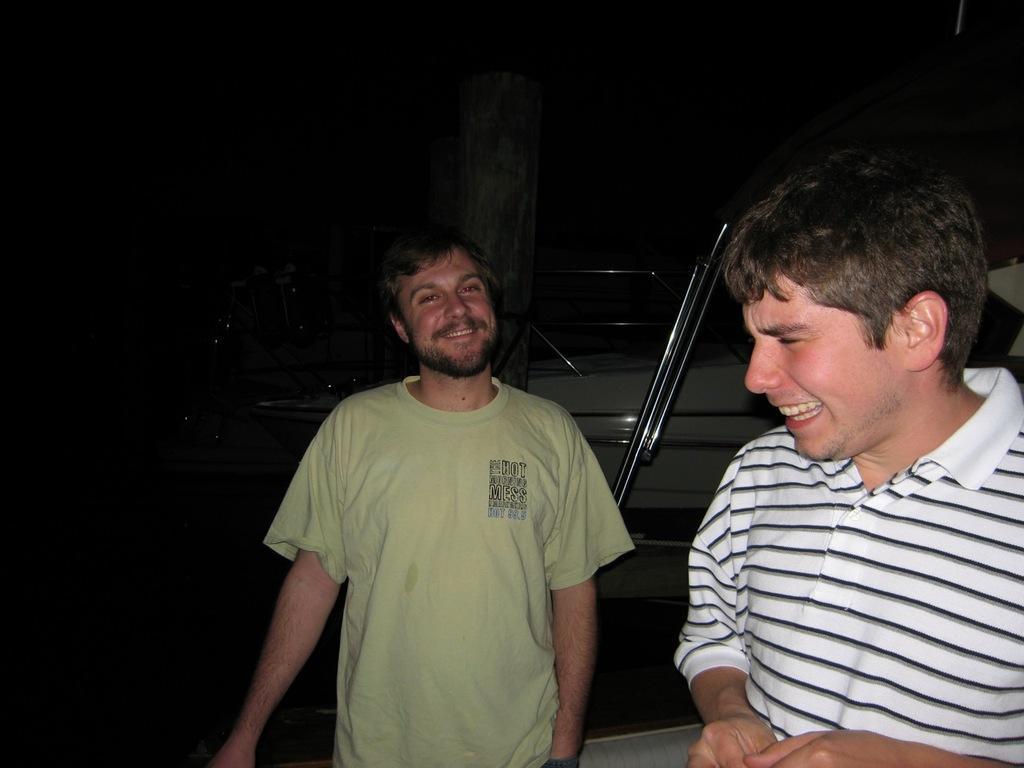Describe this image in one or two sentences. This picture is taken in night and I can see there are two persons in the foreground and they both are smiling , in the middle I can see a vehicle and a pole 